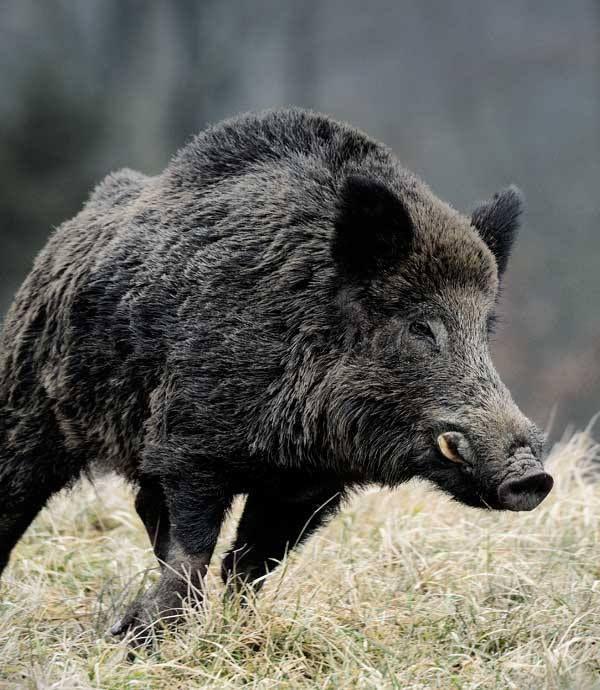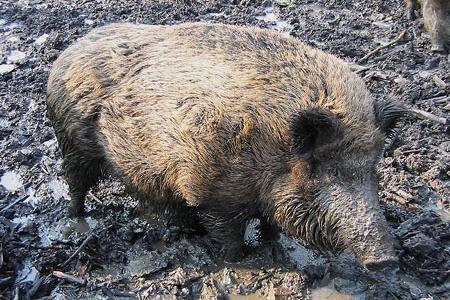The first image is the image on the left, the second image is the image on the right. Given the left and right images, does the statement "Each image shows only one pig and in one of the images that pig is in the mud." hold true? Answer yes or no. Yes. 